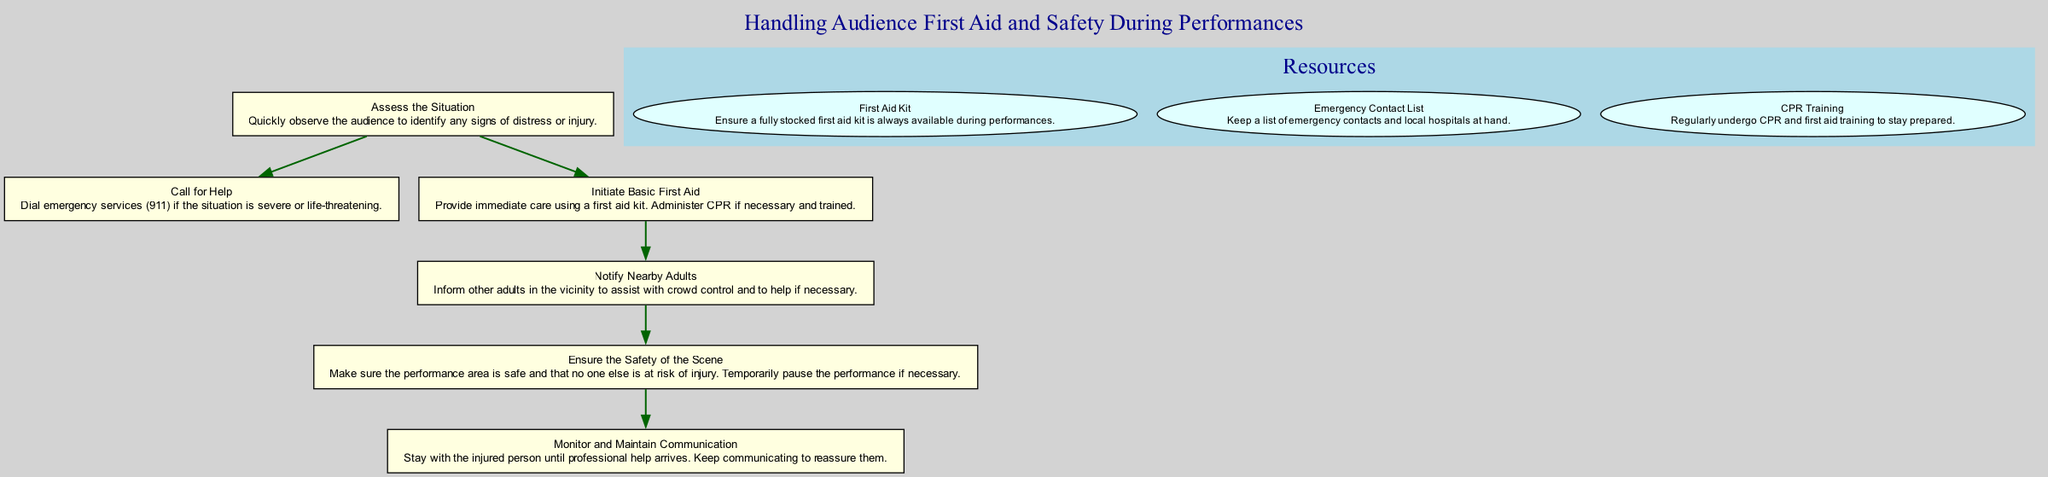What is the first step in the process? The first step in the process is to "Assess the Situation." This is indicated as the initial node in the diagram, where the process begins.
Answer: Assess the Situation How many resources are listed in the diagram? The diagram includes three resources listed in a separate cluster labeled 'Resources.' The resources are First Aid Kit, Emergency Contact List, and CPR Training. Counting those gives a total of three.
Answer: 3 What action follows the notification of nearby adults? The action following the notification of nearby adults is to "Ensure the Safety of the Scene." This is indicated as the next node that comes after the "Notify Nearby Adults" step.
Answer: Ensure the Safety of the Scene If the situation is life-threatening, what do you do? If the situation is life-threatening, the appropriate action is to "Call for Help." This is the next step that would be taken in the flow in response to a severe situation.
Answer: Call for Help Which step requires immediate care using a first aid kit? The step that requires immediate care using a first aid kit is "Initiate Basic First Aid." This step is specifically focused on providing care for injuries as quickly as possible.
Answer: Initiate Basic First Aid What is the purpose of the resources listed in the diagram? The purpose of the resources listed in the diagram is to ensure preparedness for handling first aid and emergency situations during performances. Each resource provides essential supplies or training to assist in emergencies.
Answer: Preparedness In what situation should the performance be paused? The performance should be paused when the "Ensure the Safety of the Scene" step indicates that the performance area is unsafe or if there is a risk of further injury to the audience.
Answer: When the performance area is unsafe How many steps lead to the final node in the flow? There are six steps that ultimately lead to the final node, which is "Monitor and Maintain Communication." Each step in the sequence connects to the next, creating a flow of actions to follow during an incident.
Answer: 6 